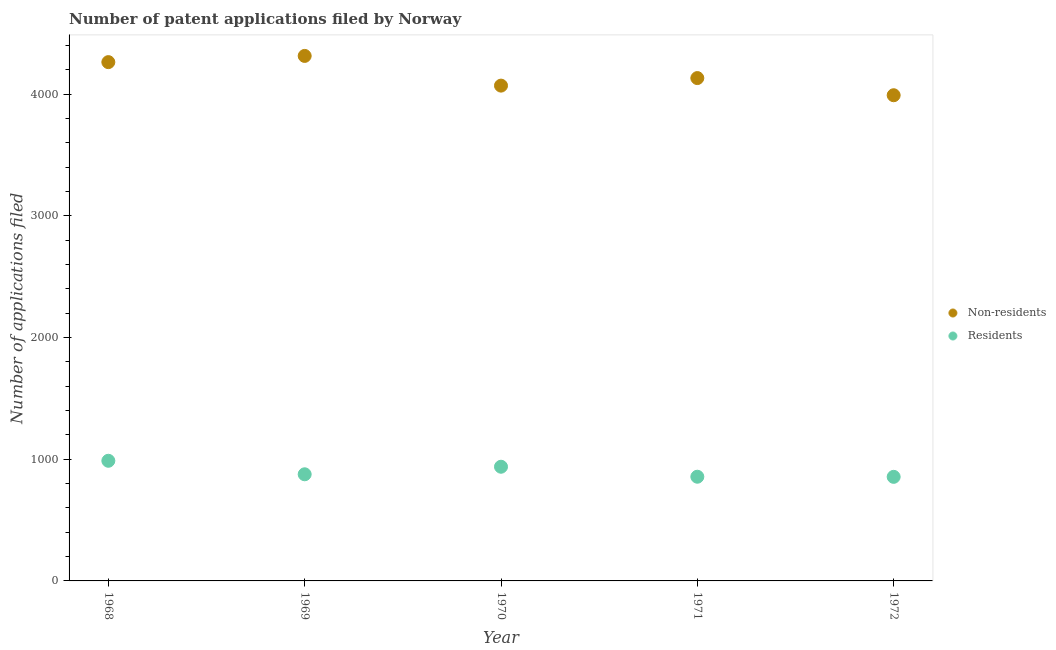How many different coloured dotlines are there?
Ensure brevity in your answer.  2. What is the number of patent applications by non residents in 1969?
Ensure brevity in your answer.  4313. Across all years, what is the maximum number of patent applications by non residents?
Provide a succinct answer. 4313. Across all years, what is the minimum number of patent applications by residents?
Give a very brief answer. 855. In which year was the number of patent applications by residents maximum?
Keep it short and to the point. 1968. In which year was the number of patent applications by non residents minimum?
Provide a succinct answer. 1972. What is the total number of patent applications by non residents in the graph?
Offer a very short reply. 2.08e+04. What is the difference between the number of patent applications by non residents in 1969 and that in 1970?
Provide a short and direct response. 244. What is the difference between the number of patent applications by non residents in 1968 and the number of patent applications by residents in 1969?
Keep it short and to the point. 3386. What is the average number of patent applications by residents per year?
Provide a succinct answer. 902.4. In the year 1970, what is the difference between the number of patent applications by non residents and number of patent applications by residents?
Your answer should be compact. 3131. In how many years, is the number of patent applications by non residents greater than 1600?
Give a very brief answer. 5. What is the ratio of the number of patent applications by non residents in 1968 to that in 1971?
Offer a very short reply. 1.03. Is the number of patent applications by residents in 1970 less than that in 1971?
Your answer should be compact. No. What is the difference between the highest and the second highest number of patent applications by residents?
Your answer should be compact. 49. What is the difference between the highest and the lowest number of patent applications by non residents?
Provide a short and direct response. 323. Is the sum of the number of patent applications by residents in 1968 and 1972 greater than the maximum number of patent applications by non residents across all years?
Your answer should be very brief. No. Is the number of patent applications by non residents strictly greater than the number of patent applications by residents over the years?
Provide a short and direct response. Yes. Is the number of patent applications by non residents strictly less than the number of patent applications by residents over the years?
Give a very brief answer. No. How many dotlines are there?
Offer a terse response. 2. How many years are there in the graph?
Give a very brief answer. 5. What is the difference between two consecutive major ticks on the Y-axis?
Your answer should be very brief. 1000. Does the graph contain grids?
Your answer should be very brief. No. Where does the legend appear in the graph?
Offer a very short reply. Center right. How many legend labels are there?
Your response must be concise. 2. What is the title of the graph?
Offer a very short reply. Number of patent applications filed by Norway. What is the label or title of the Y-axis?
Make the answer very short. Number of applications filed. What is the Number of applications filed in Non-residents in 1968?
Ensure brevity in your answer.  4262. What is the Number of applications filed in Residents in 1968?
Your answer should be very brief. 987. What is the Number of applications filed of Non-residents in 1969?
Offer a terse response. 4313. What is the Number of applications filed of Residents in 1969?
Your answer should be very brief. 876. What is the Number of applications filed of Non-residents in 1970?
Give a very brief answer. 4069. What is the Number of applications filed in Residents in 1970?
Keep it short and to the point. 938. What is the Number of applications filed in Non-residents in 1971?
Ensure brevity in your answer.  4131. What is the Number of applications filed of Residents in 1971?
Offer a terse response. 856. What is the Number of applications filed in Non-residents in 1972?
Make the answer very short. 3990. What is the Number of applications filed of Residents in 1972?
Provide a short and direct response. 855. Across all years, what is the maximum Number of applications filed in Non-residents?
Offer a very short reply. 4313. Across all years, what is the maximum Number of applications filed of Residents?
Your answer should be very brief. 987. Across all years, what is the minimum Number of applications filed of Non-residents?
Offer a terse response. 3990. Across all years, what is the minimum Number of applications filed in Residents?
Keep it short and to the point. 855. What is the total Number of applications filed in Non-residents in the graph?
Give a very brief answer. 2.08e+04. What is the total Number of applications filed in Residents in the graph?
Offer a very short reply. 4512. What is the difference between the Number of applications filed of Non-residents in 1968 and that in 1969?
Provide a short and direct response. -51. What is the difference between the Number of applications filed in Residents in 1968 and that in 1969?
Provide a succinct answer. 111. What is the difference between the Number of applications filed of Non-residents in 1968 and that in 1970?
Offer a very short reply. 193. What is the difference between the Number of applications filed of Residents in 1968 and that in 1970?
Give a very brief answer. 49. What is the difference between the Number of applications filed of Non-residents in 1968 and that in 1971?
Your answer should be compact. 131. What is the difference between the Number of applications filed of Residents in 1968 and that in 1971?
Offer a very short reply. 131. What is the difference between the Number of applications filed of Non-residents in 1968 and that in 1972?
Your answer should be very brief. 272. What is the difference between the Number of applications filed in Residents in 1968 and that in 1972?
Give a very brief answer. 132. What is the difference between the Number of applications filed in Non-residents in 1969 and that in 1970?
Keep it short and to the point. 244. What is the difference between the Number of applications filed of Residents in 1969 and that in 1970?
Your response must be concise. -62. What is the difference between the Number of applications filed of Non-residents in 1969 and that in 1971?
Your answer should be compact. 182. What is the difference between the Number of applications filed in Non-residents in 1969 and that in 1972?
Ensure brevity in your answer.  323. What is the difference between the Number of applications filed in Residents in 1969 and that in 1972?
Offer a terse response. 21. What is the difference between the Number of applications filed in Non-residents in 1970 and that in 1971?
Ensure brevity in your answer.  -62. What is the difference between the Number of applications filed in Non-residents in 1970 and that in 1972?
Give a very brief answer. 79. What is the difference between the Number of applications filed of Non-residents in 1971 and that in 1972?
Make the answer very short. 141. What is the difference between the Number of applications filed in Residents in 1971 and that in 1972?
Offer a terse response. 1. What is the difference between the Number of applications filed in Non-residents in 1968 and the Number of applications filed in Residents in 1969?
Make the answer very short. 3386. What is the difference between the Number of applications filed in Non-residents in 1968 and the Number of applications filed in Residents in 1970?
Give a very brief answer. 3324. What is the difference between the Number of applications filed of Non-residents in 1968 and the Number of applications filed of Residents in 1971?
Give a very brief answer. 3406. What is the difference between the Number of applications filed in Non-residents in 1968 and the Number of applications filed in Residents in 1972?
Your answer should be compact. 3407. What is the difference between the Number of applications filed of Non-residents in 1969 and the Number of applications filed of Residents in 1970?
Give a very brief answer. 3375. What is the difference between the Number of applications filed of Non-residents in 1969 and the Number of applications filed of Residents in 1971?
Offer a terse response. 3457. What is the difference between the Number of applications filed in Non-residents in 1969 and the Number of applications filed in Residents in 1972?
Give a very brief answer. 3458. What is the difference between the Number of applications filed in Non-residents in 1970 and the Number of applications filed in Residents in 1971?
Give a very brief answer. 3213. What is the difference between the Number of applications filed in Non-residents in 1970 and the Number of applications filed in Residents in 1972?
Offer a terse response. 3214. What is the difference between the Number of applications filed in Non-residents in 1971 and the Number of applications filed in Residents in 1972?
Give a very brief answer. 3276. What is the average Number of applications filed in Non-residents per year?
Give a very brief answer. 4153. What is the average Number of applications filed of Residents per year?
Offer a terse response. 902.4. In the year 1968, what is the difference between the Number of applications filed of Non-residents and Number of applications filed of Residents?
Ensure brevity in your answer.  3275. In the year 1969, what is the difference between the Number of applications filed in Non-residents and Number of applications filed in Residents?
Make the answer very short. 3437. In the year 1970, what is the difference between the Number of applications filed in Non-residents and Number of applications filed in Residents?
Give a very brief answer. 3131. In the year 1971, what is the difference between the Number of applications filed in Non-residents and Number of applications filed in Residents?
Offer a very short reply. 3275. In the year 1972, what is the difference between the Number of applications filed of Non-residents and Number of applications filed of Residents?
Provide a short and direct response. 3135. What is the ratio of the Number of applications filed in Residents in 1968 to that in 1969?
Your answer should be compact. 1.13. What is the ratio of the Number of applications filed of Non-residents in 1968 to that in 1970?
Offer a terse response. 1.05. What is the ratio of the Number of applications filed in Residents in 1968 to that in 1970?
Keep it short and to the point. 1.05. What is the ratio of the Number of applications filed of Non-residents in 1968 to that in 1971?
Offer a very short reply. 1.03. What is the ratio of the Number of applications filed in Residents in 1968 to that in 1971?
Your answer should be compact. 1.15. What is the ratio of the Number of applications filed in Non-residents in 1968 to that in 1972?
Ensure brevity in your answer.  1.07. What is the ratio of the Number of applications filed of Residents in 1968 to that in 1972?
Give a very brief answer. 1.15. What is the ratio of the Number of applications filed of Non-residents in 1969 to that in 1970?
Your answer should be very brief. 1.06. What is the ratio of the Number of applications filed of Residents in 1969 to that in 1970?
Offer a very short reply. 0.93. What is the ratio of the Number of applications filed in Non-residents in 1969 to that in 1971?
Make the answer very short. 1.04. What is the ratio of the Number of applications filed of Residents in 1969 to that in 1971?
Your answer should be very brief. 1.02. What is the ratio of the Number of applications filed in Non-residents in 1969 to that in 1972?
Your response must be concise. 1.08. What is the ratio of the Number of applications filed in Residents in 1969 to that in 1972?
Offer a terse response. 1.02. What is the ratio of the Number of applications filed of Residents in 1970 to that in 1971?
Provide a succinct answer. 1.1. What is the ratio of the Number of applications filed of Non-residents in 1970 to that in 1972?
Give a very brief answer. 1.02. What is the ratio of the Number of applications filed in Residents in 1970 to that in 1972?
Ensure brevity in your answer.  1.1. What is the ratio of the Number of applications filed of Non-residents in 1971 to that in 1972?
Offer a terse response. 1.04. What is the difference between the highest and the second highest Number of applications filed in Residents?
Your answer should be compact. 49. What is the difference between the highest and the lowest Number of applications filed of Non-residents?
Offer a terse response. 323. What is the difference between the highest and the lowest Number of applications filed in Residents?
Your response must be concise. 132. 